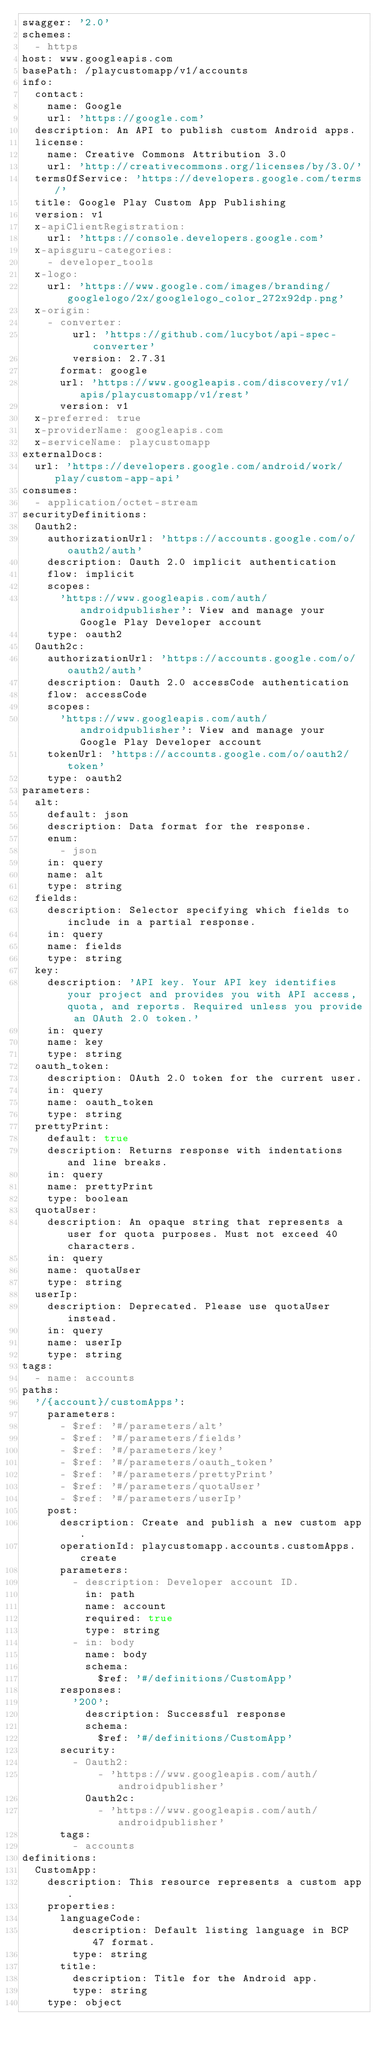Convert code to text. <code><loc_0><loc_0><loc_500><loc_500><_YAML_>swagger: '2.0'
schemes:
  - https
host: www.googleapis.com
basePath: /playcustomapp/v1/accounts
info:
  contact:
    name: Google
    url: 'https://google.com'
  description: An API to publish custom Android apps.
  license:
    name: Creative Commons Attribution 3.0
    url: 'http://creativecommons.org/licenses/by/3.0/'
  termsOfService: 'https://developers.google.com/terms/'
  title: Google Play Custom App Publishing
  version: v1
  x-apiClientRegistration:
    url: 'https://console.developers.google.com'
  x-apisguru-categories:
    - developer_tools
  x-logo:
    url: 'https://www.google.com/images/branding/googlelogo/2x/googlelogo_color_272x92dp.png'
  x-origin:
    - converter:
        url: 'https://github.com/lucybot/api-spec-converter'
        version: 2.7.31
      format: google
      url: 'https://www.googleapis.com/discovery/v1/apis/playcustomapp/v1/rest'
      version: v1
  x-preferred: true
  x-providerName: googleapis.com
  x-serviceName: playcustomapp
externalDocs:
  url: 'https://developers.google.com/android/work/play/custom-app-api'
consumes:
  - application/octet-stream
securityDefinitions:
  Oauth2:
    authorizationUrl: 'https://accounts.google.com/o/oauth2/auth'
    description: Oauth 2.0 implicit authentication
    flow: implicit
    scopes:
      'https://www.googleapis.com/auth/androidpublisher': View and manage your Google Play Developer account
    type: oauth2
  Oauth2c:
    authorizationUrl: 'https://accounts.google.com/o/oauth2/auth'
    description: Oauth 2.0 accessCode authentication
    flow: accessCode
    scopes:
      'https://www.googleapis.com/auth/androidpublisher': View and manage your Google Play Developer account
    tokenUrl: 'https://accounts.google.com/o/oauth2/token'
    type: oauth2
parameters:
  alt:
    default: json
    description: Data format for the response.
    enum:
      - json
    in: query
    name: alt
    type: string
  fields:
    description: Selector specifying which fields to include in a partial response.
    in: query
    name: fields
    type: string
  key:
    description: 'API key. Your API key identifies your project and provides you with API access, quota, and reports. Required unless you provide an OAuth 2.0 token.'
    in: query
    name: key
    type: string
  oauth_token:
    description: OAuth 2.0 token for the current user.
    in: query
    name: oauth_token
    type: string
  prettyPrint:
    default: true
    description: Returns response with indentations and line breaks.
    in: query
    name: prettyPrint
    type: boolean
  quotaUser:
    description: An opaque string that represents a user for quota purposes. Must not exceed 40 characters.
    in: query
    name: quotaUser
    type: string
  userIp:
    description: Deprecated. Please use quotaUser instead.
    in: query
    name: userIp
    type: string
tags:
  - name: accounts
paths:
  '/{account}/customApps':
    parameters:
      - $ref: '#/parameters/alt'
      - $ref: '#/parameters/fields'
      - $ref: '#/parameters/key'
      - $ref: '#/parameters/oauth_token'
      - $ref: '#/parameters/prettyPrint'
      - $ref: '#/parameters/quotaUser'
      - $ref: '#/parameters/userIp'
    post:
      description: Create and publish a new custom app.
      operationId: playcustomapp.accounts.customApps.create
      parameters:
        - description: Developer account ID.
          in: path
          name: account
          required: true
          type: string
        - in: body
          name: body
          schema:
            $ref: '#/definitions/CustomApp'
      responses:
        '200':
          description: Successful response
          schema:
            $ref: '#/definitions/CustomApp'
      security:
        - Oauth2:
            - 'https://www.googleapis.com/auth/androidpublisher'
          Oauth2c:
            - 'https://www.googleapis.com/auth/androidpublisher'
      tags:
        - accounts
definitions:
  CustomApp:
    description: This resource represents a custom app.
    properties:
      languageCode:
        description: Default listing language in BCP 47 format.
        type: string
      title:
        description: Title for the Android app.
        type: string
    type: object
</code> 